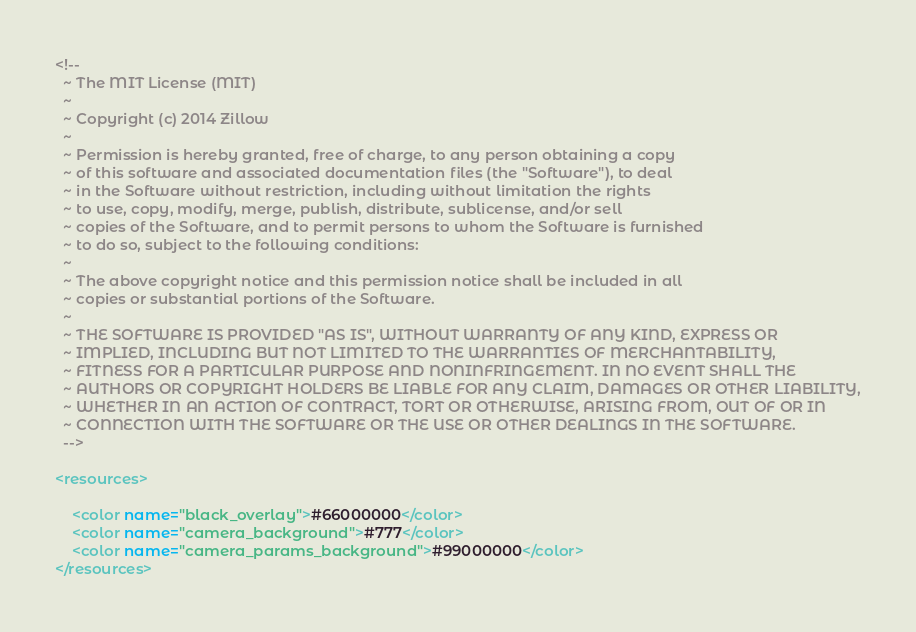<code> <loc_0><loc_0><loc_500><loc_500><_XML_><!--
  ~ The MIT License (MIT)
  ~
  ~ Copyright (c) 2014 Zillow
  ~
  ~ Permission is hereby granted, free of charge, to any person obtaining a copy
  ~ of this software and associated documentation files (the "Software"), to deal
  ~ in the Software without restriction, including without limitation the rights
  ~ to use, copy, modify, merge, publish, distribute, sublicense, and/or sell
  ~ copies of the Software, and to permit persons to whom the Software is furnished
  ~ to do so, subject to the following conditions:
  ~
  ~ The above copyright notice and this permission notice shall be included in all
  ~ copies or substantial portions of the Software.
  ~
  ~ THE SOFTWARE IS PROVIDED "AS IS", WITHOUT WARRANTY OF ANY KIND, EXPRESS OR
  ~ IMPLIED, INCLUDING BUT NOT LIMITED TO THE WARRANTIES OF MERCHANTABILITY,
  ~ FITNESS FOR A PARTICULAR PURPOSE AND NONINFRINGEMENT. IN NO EVENT SHALL THE
  ~ AUTHORS OR COPYRIGHT HOLDERS BE LIABLE FOR ANY CLAIM, DAMAGES OR OTHER LIABILITY,
  ~ WHETHER IN AN ACTION OF CONTRACT, TORT OR OTHERWISE, ARISING FROM, OUT OF OR IN
  ~ CONNECTION WITH THE SOFTWARE OR THE USE OR OTHER DEALINGS IN THE SOFTWARE.
  -->

<resources>

    <color name="black_overlay">#66000000</color>
    <color name="camera_background">#777</color>
    <color name="camera_params_background">#99000000</color>
</resources>
</code> 